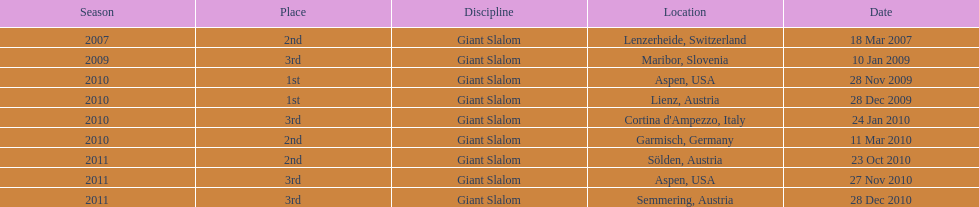Where was her first win? Aspen, USA. 